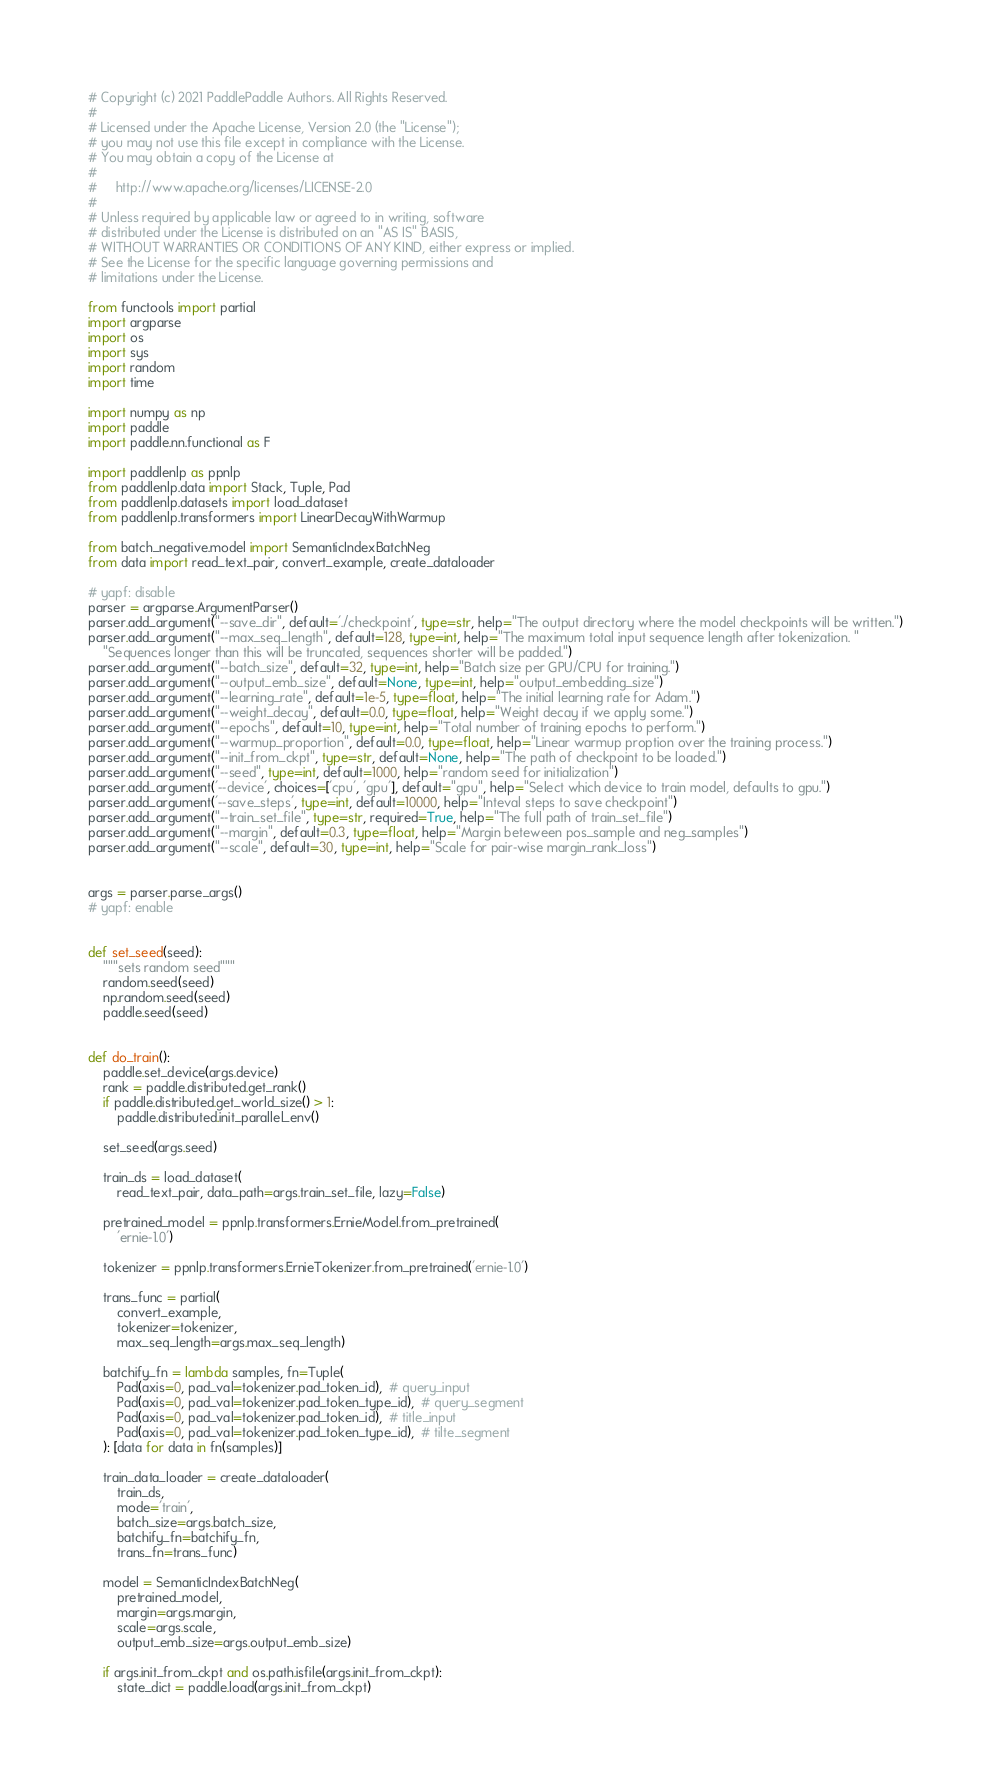<code> <loc_0><loc_0><loc_500><loc_500><_Python_># Copyright (c) 2021 PaddlePaddle Authors. All Rights Reserved.
#
# Licensed under the Apache License, Version 2.0 (the "License");
# you may not use this file except in compliance with the License.
# You may obtain a copy of the License at
#
#     http://www.apache.org/licenses/LICENSE-2.0
#
# Unless required by applicable law or agreed to in writing, software
# distributed under the License is distributed on an "AS IS" BASIS,
# WITHOUT WARRANTIES OR CONDITIONS OF ANY KIND, either express or implied.
# See the License for the specific language governing permissions and
# limitations under the License.

from functools import partial
import argparse
import os
import sys
import random
import time

import numpy as np
import paddle
import paddle.nn.functional as F

import paddlenlp as ppnlp
from paddlenlp.data import Stack, Tuple, Pad
from paddlenlp.datasets import load_dataset
from paddlenlp.transformers import LinearDecayWithWarmup

from batch_negative.model import SemanticIndexBatchNeg
from data import read_text_pair, convert_example, create_dataloader

# yapf: disable
parser = argparse.ArgumentParser()
parser.add_argument("--save_dir", default='./checkpoint', type=str, help="The output directory where the model checkpoints will be written.")
parser.add_argument("--max_seq_length", default=128, type=int, help="The maximum total input sequence length after tokenization. "
    "Sequences longer than this will be truncated, sequences shorter will be padded.")
parser.add_argument("--batch_size", default=32, type=int, help="Batch size per GPU/CPU for training.")
parser.add_argument("--output_emb_size", default=None, type=int, help="output_embedding_size")
parser.add_argument("--learning_rate", default=1e-5, type=float, help="The initial learning rate for Adam.")
parser.add_argument("--weight_decay", default=0.0, type=float, help="Weight decay if we apply some.")
parser.add_argument("--epochs", default=10, type=int, help="Total number of training epochs to perform.")
parser.add_argument("--warmup_proportion", default=0.0, type=float, help="Linear warmup proption over the training process.")
parser.add_argument("--init_from_ckpt", type=str, default=None, help="The path of checkpoint to be loaded.")
parser.add_argument("--seed", type=int, default=1000, help="random seed for initialization")
parser.add_argument('--device', choices=['cpu', 'gpu'], default="gpu", help="Select which device to train model, defaults to gpu.")
parser.add_argument('--save_steps', type=int, default=10000, help="Inteval steps to save checkpoint")
parser.add_argument("--train_set_file", type=str, required=True, help="The full path of train_set_file")
parser.add_argument("--margin", default=0.3, type=float, help="Margin beteween pos_sample and neg_samples")
parser.add_argument("--scale", default=30, type=int, help="Scale for pair-wise margin_rank_loss")


args = parser.parse_args()
# yapf: enable


def set_seed(seed):
    """sets random seed"""
    random.seed(seed)
    np.random.seed(seed)
    paddle.seed(seed)


def do_train():
    paddle.set_device(args.device)
    rank = paddle.distributed.get_rank()
    if paddle.distributed.get_world_size() > 1:
        paddle.distributed.init_parallel_env()

    set_seed(args.seed)

    train_ds = load_dataset(
        read_text_pair, data_path=args.train_set_file, lazy=False)

    pretrained_model = ppnlp.transformers.ErnieModel.from_pretrained(
        'ernie-1.0')

    tokenizer = ppnlp.transformers.ErnieTokenizer.from_pretrained('ernie-1.0')

    trans_func = partial(
        convert_example,
        tokenizer=tokenizer,
        max_seq_length=args.max_seq_length)

    batchify_fn = lambda samples, fn=Tuple(
        Pad(axis=0, pad_val=tokenizer.pad_token_id),  # query_input
        Pad(axis=0, pad_val=tokenizer.pad_token_type_id),  # query_segment
        Pad(axis=0, pad_val=tokenizer.pad_token_id),  # title_input
        Pad(axis=0, pad_val=tokenizer.pad_token_type_id),  # tilte_segment
    ): [data for data in fn(samples)]

    train_data_loader = create_dataloader(
        train_ds,
        mode='train',
        batch_size=args.batch_size,
        batchify_fn=batchify_fn,
        trans_fn=trans_func)

    model = SemanticIndexBatchNeg(
        pretrained_model,
        margin=args.margin,
        scale=args.scale,
        output_emb_size=args.output_emb_size)

    if args.init_from_ckpt and os.path.isfile(args.init_from_ckpt):
        state_dict = paddle.load(args.init_from_ckpt)</code> 